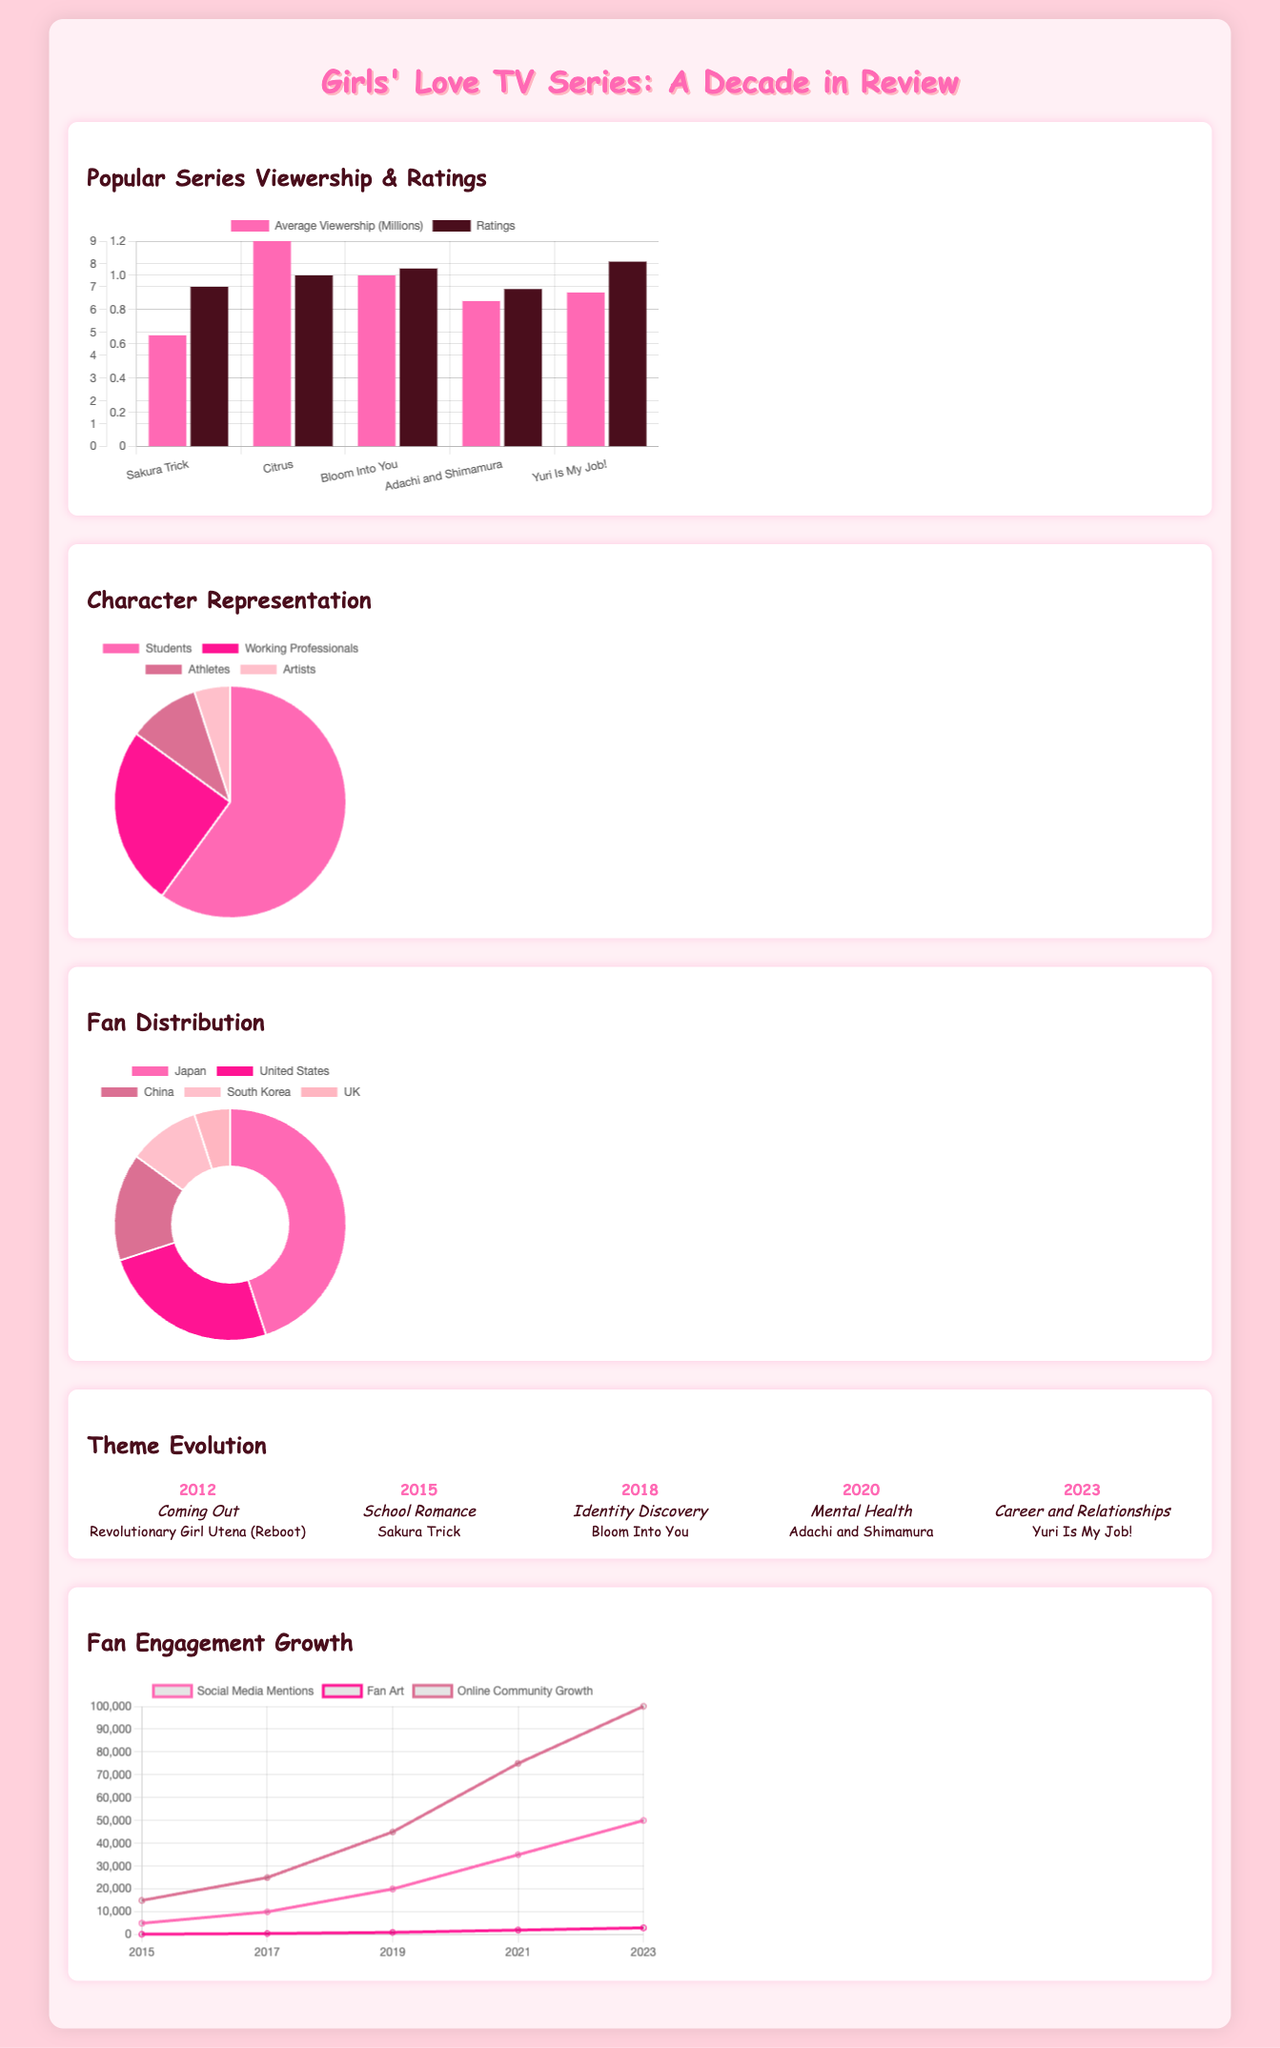What is the average viewership of 'Yuri Is My Job!'? The average viewership is listed in the chart comparing popular series, specifically 0.9 million.
Answer: 0.9 million Which series has the highest rating? The chart shows 'Yuri Is My Job!' has the highest rating of 8.1.
Answer: 8.1 What percentage of characters are Students? The pie chart for character representation indicates that 60% of characters are Students.
Answer: 60% Which region has the most fans? The doughnut chart highlights that Japan has the largest fan distribution with 45%.
Answer: Japan In what year did the theme 'Mental Health' appear? The timeline indicates the theme 'Mental Health' was introduced in 2020.
Answer: 2020 How many social media mentions were recorded in 2023? The engagement growth chart shows 50,000 social media mentions in 2023.
Answer: 50000 What is the lowest percentage of character representation? The character representation chart indicates that 5% of characters are Artists, which is the lowest.
Answer: 5% What is the growth of online community from 2019 to 2023? The data shows an increase from 45,000 to 100,000 online community members, indicating considerable growth.
Answer: 55000 Which series represents the theme of 'Identity Discovery'? The timeline specifies that 'Bloom Into You' represents the theme of 'Identity Discovery.'
Answer: Bloom Into You 